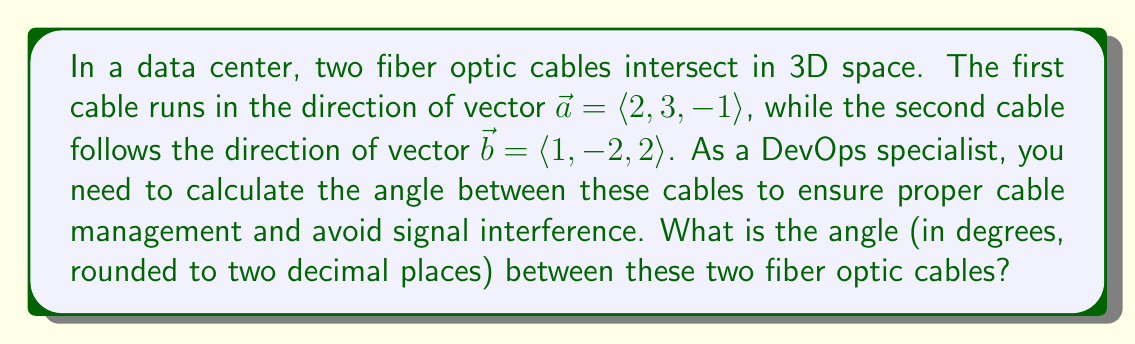Show me your answer to this math problem. To find the angle between two vectors in 3D space, we can use the dot product formula:

$$\cos \theta = \frac{\vec{a} \cdot \vec{b}}{|\vec{a}| |\vec{b}|}$$

Where $\theta$ is the angle between the vectors, $\vec{a} \cdot \vec{b}$ is the dot product of the vectors, and $|\vec{a}|$ and $|\vec{b}|$ are the magnitudes of vectors $\vec{a}$ and $\vec{b}$ respectively.

Let's solve this step-by-step:

1. Calculate the dot product $\vec{a} \cdot \vec{b}$:
   $$\vec{a} \cdot \vec{b} = (2)(1) + (3)(-2) + (-1)(2) = 2 - 6 - 2 = -6$$

2. Calculate the magnitude of $\vec{a}$:
   $$|\vec{a}| = \sqrt{2^2 + 3^2 + (-1)^2} = \sqrt{4 + 9 + 1} = \sqrt{14}$$

3. Calculate the magnitude of $\vec{b}$:
   $$|\vec{b}| = \sqrt{1^2 + (-2)^2 + 2^2} = \sqrt{1 + 4 + 4} = 3$$

4. Apply the dot product formula:
   $$\cos \theta = \frac{-6}{\sqrt{14} \cdot 3} = \frac{-6}{3\sqrt{14}}$$

5. Take the inverse cosine (arccos) of both sides:
   $$\theta = \arccos\left(\frac{-6}{3\sqrt{14}}\right)$$

6. Calculate the result and convert to degrees:
   $$\theta \approx 2.0344 \text{ radians} \approx 116.57°$$

7. Round to two decimal places:
   $$\theta \approx 116.57°$$

This angle represents the acute angle between the cables. If you need the obtuse angle, you can subtract this result from 180°.
Answer: The angle between the two fiber optic cables is approximately 116.57°. 